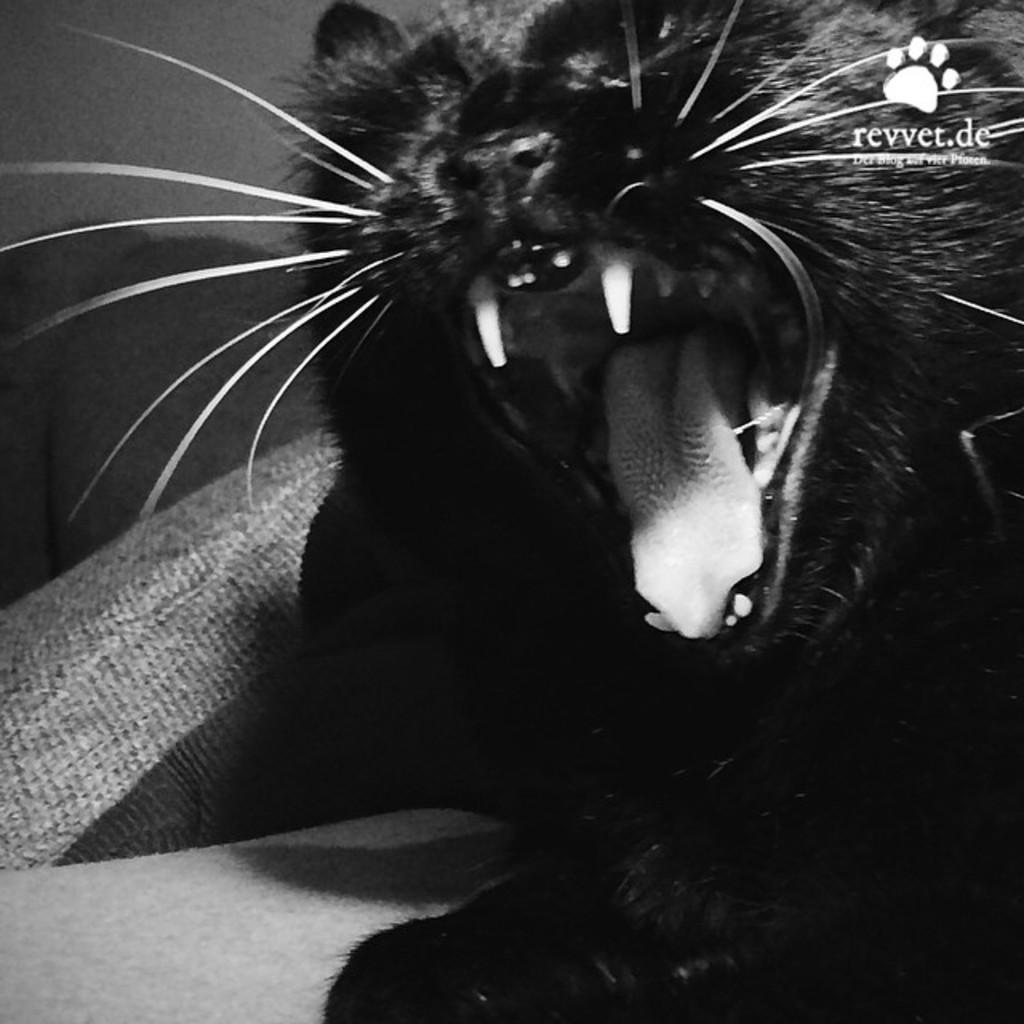What type of animal can be seen in the image? There is a cat in the image. What is located on the left side of the sofa in the image? There is a cushion on the left side of the sofa in the image. What is visible at the back of the image? There is a wall at the back of the image. Where is the text located in the image? The text is at the top right of the image. Can you see a horse in the image? No, there is no horse present in the image. What type of sign is visible in the image? There is no sign visible in the image. 